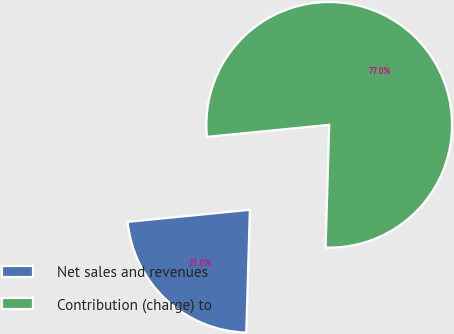<chart> <loc_0><loc_0><loc_500><loc_500><pie_chart><fcel>Net sales and revenues<fcel>Contribution (charge) to<nl><fcel>22.97%<fcel>77.03%<nl></chart> 